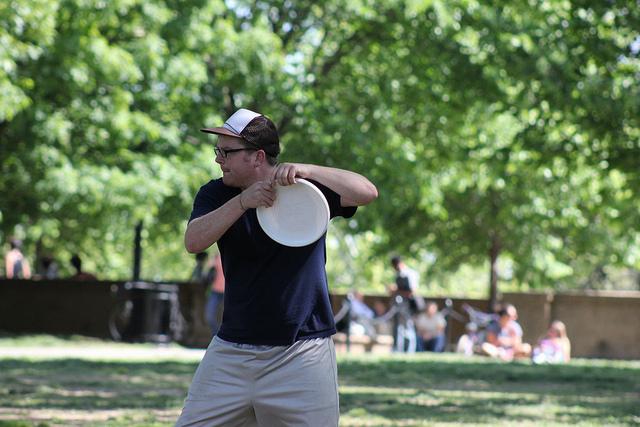Is the man wearing glasses?
Quick response, please. Yes. What is this man about to throw?
Short answer required. Frisbee. Are there people in the background?
Write a very short answer. Yes. 